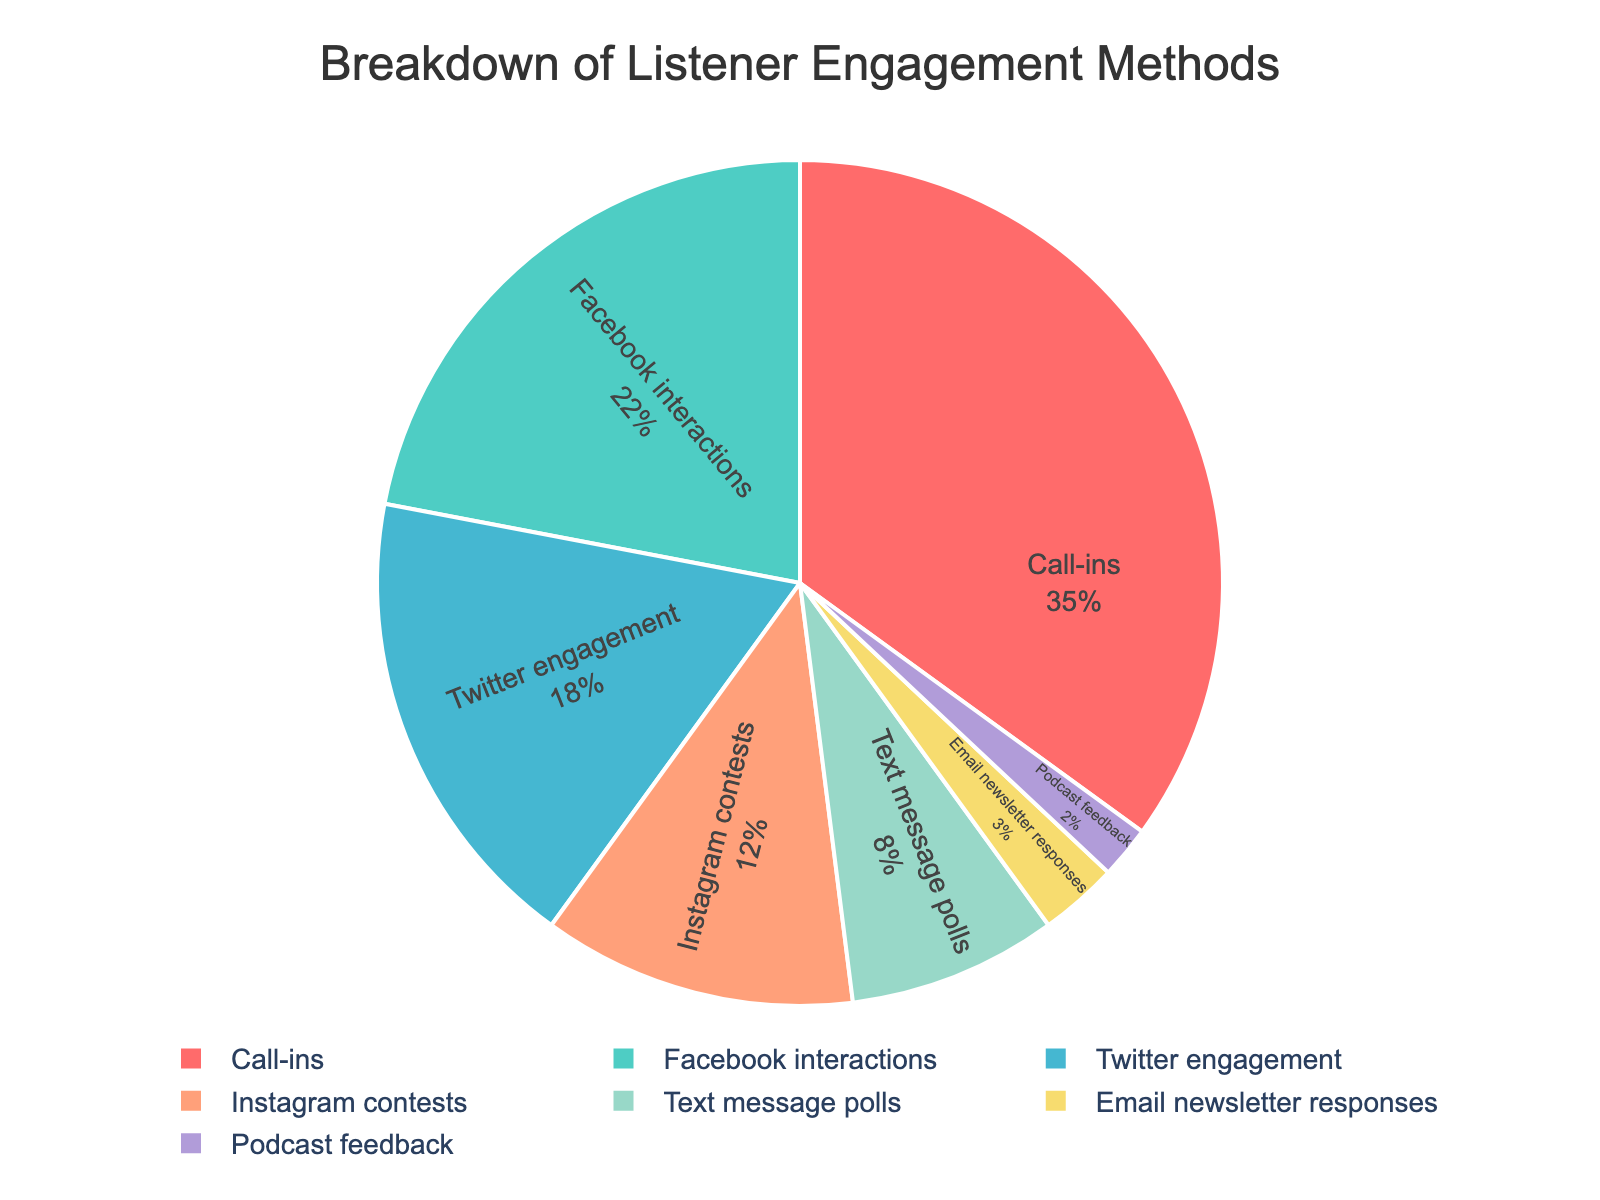What's the most popular engagement method among listeners? The most popular engagement method would be the one with the highest percentage in the pie chart. From the figure, the "Call-ins" segment is the largest and represents 35% of the total engagement.
Answer: Call-ins Which engagement method has the lowest percentage? The least popular engagement method would be the one with the smallest segment in the pie chart. According to the chart, "Podcast feedback" has the smallest segment at 2%.
Answer: Podcast feedback What is the combined percentage of social media interactions (Facebook, Twitter, Instagram)? To find the combined percentage, add the percentages for Facebook interactions, Twitter engagement, and Instagram contests. These are 22%, 18%, and 12%, respectively. So, 22 + 18 + 12 = 52%.
Answer: 52% How does the percentage of text message polls compare to email newsletter responses? We need to compare the values for text message polls and email newsletter responses. Text message polls account for 8%, while email newsletter responses account for 3%. Therefore, text message polls are greater.
Answer: Text message polls are greater What is the difference in percentage between the highest and lowest engagement methods? The highest engagement method is "Call-ins" at 35%, and the lowest is "Podcast feedback" at 2%. The difference is 35 - 2 = 33%.
Answer: 33% Which segment appears in blue color in the chart? To identify the segment by color, we note that "Twitter engagement" is represented in blue in the customized color palette provided.
Answer: Twitter engagement If we combine the percentages of all methods except for the top two, what's the total? The top two methods are "Call-ins" (35%) and "Facebook interactions" (22%). So we sum the percentages of the remaining methods: 18 (Twitter) + 12 (Instagram contests) + 8 (Text message polls) + 3 (Email newsletter responses) + 2 (Podcast feedback) = 43%
Answer: 43% Out of the remaining methods other than the top three, which has the second-highest percentage? Excluding the top three methods (Call-ins, Facebook interactions, and Twitter engagement), we look at the remaining segments: Instagram contests (12%), Text message polls (8%), Email newsletter responses (3%), and Podcast feedback (2%). The method with the second-highest percentage among these is Text message polls.
Answer: Text message polls How much more engagement does Facebook have compared to Instagram contests? The engagement for Facebook interactions is 22% and for Instagram contests is 12%. The difference is 22 - 12 = 10%.
Answer: 10% What is the average percentage for Instagram contests, text message polls, and email newsletter responses? To find the average percentage, add the percentages for Instagram contests (12%), text message polls (8%), and email newsletter responses (3%) and then divide by 3. So, (12 + 8 + 3)/3 = 23/3 ≈ 7.67%.
Answer: 7.67% 